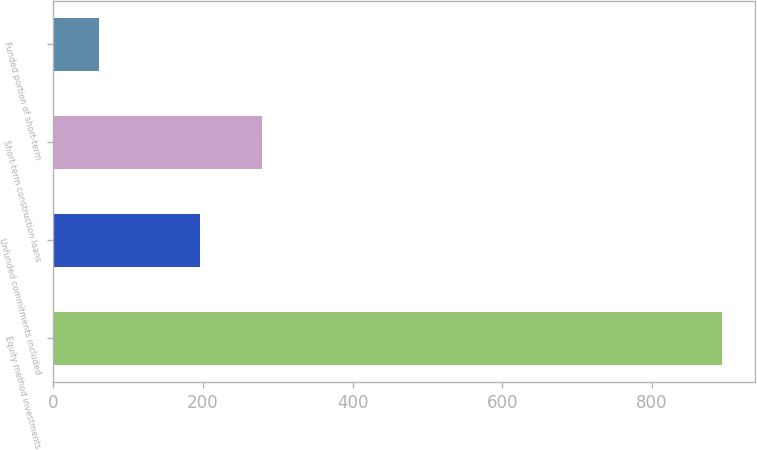<chart> <loc_0><loc_0><loc_500><loc_500><bar_chart><fcel>Equity method investments<fcel>Unfunded commitments included<fcel>Short-term construction loans<fcel>Funded portion of short-term<nl><fcel>893<fcel>196<fcel>279.2<fcel>61<nl></chart> 